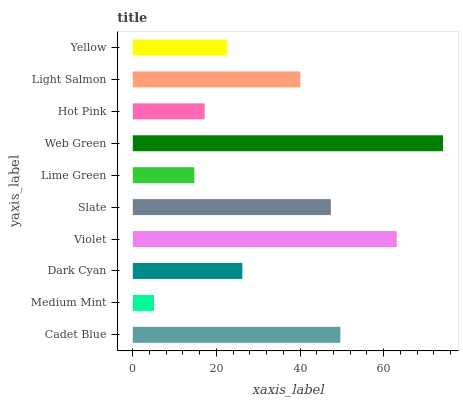Is Medium Mint the minimum?
Answer yes or no. Yes. Is Web Green the maximum?
Answer yes or no. Yes. Is Dark Cyan the minimum?
Answer yes or no. No. Is Dark Cyan the maximum?
Answer yes or no. No. Is Dark Cyan greater than Medium Mint?
Answer yes or no. Yes. Is Medium Mint less than Dark Cyan?
Answer yes or no. Yes. Is Medium Mint greater than Dark Cyan?
Answer yes or no. No. Is Dark Cyan less than Medium Mint?
Answer yes or no. No. Is Light Salmon the high median?
Answer yes or no. Yes. Is Dark Cyan the low median?
Answer yes or no. Yes. Is Medium Mint the high median?
Answer yes or no. No. Is Lime Green the low median?
Answer yes or no. No. 